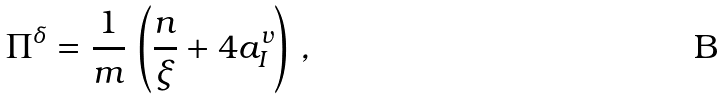<formula> <loc_0><loc_0><loc_500><loc_500>\Pi ^ { \delta } = \frac { 1 } { m } \, \left ( \frac { n } { \xi } + 4 a _ { I } ^ { v } \right ) \, ,</formula> 